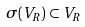<formula> <loc_0><loc_0><loc_500><loc_500>\sigma ( V _ { R } ) \subset V _ { R }</formula> 